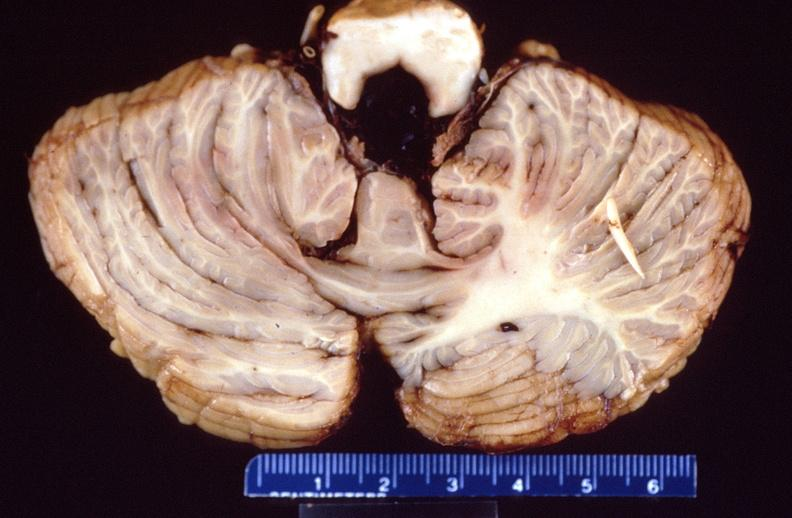what is present?
Answer the question using a single word or phrase. Nervous 